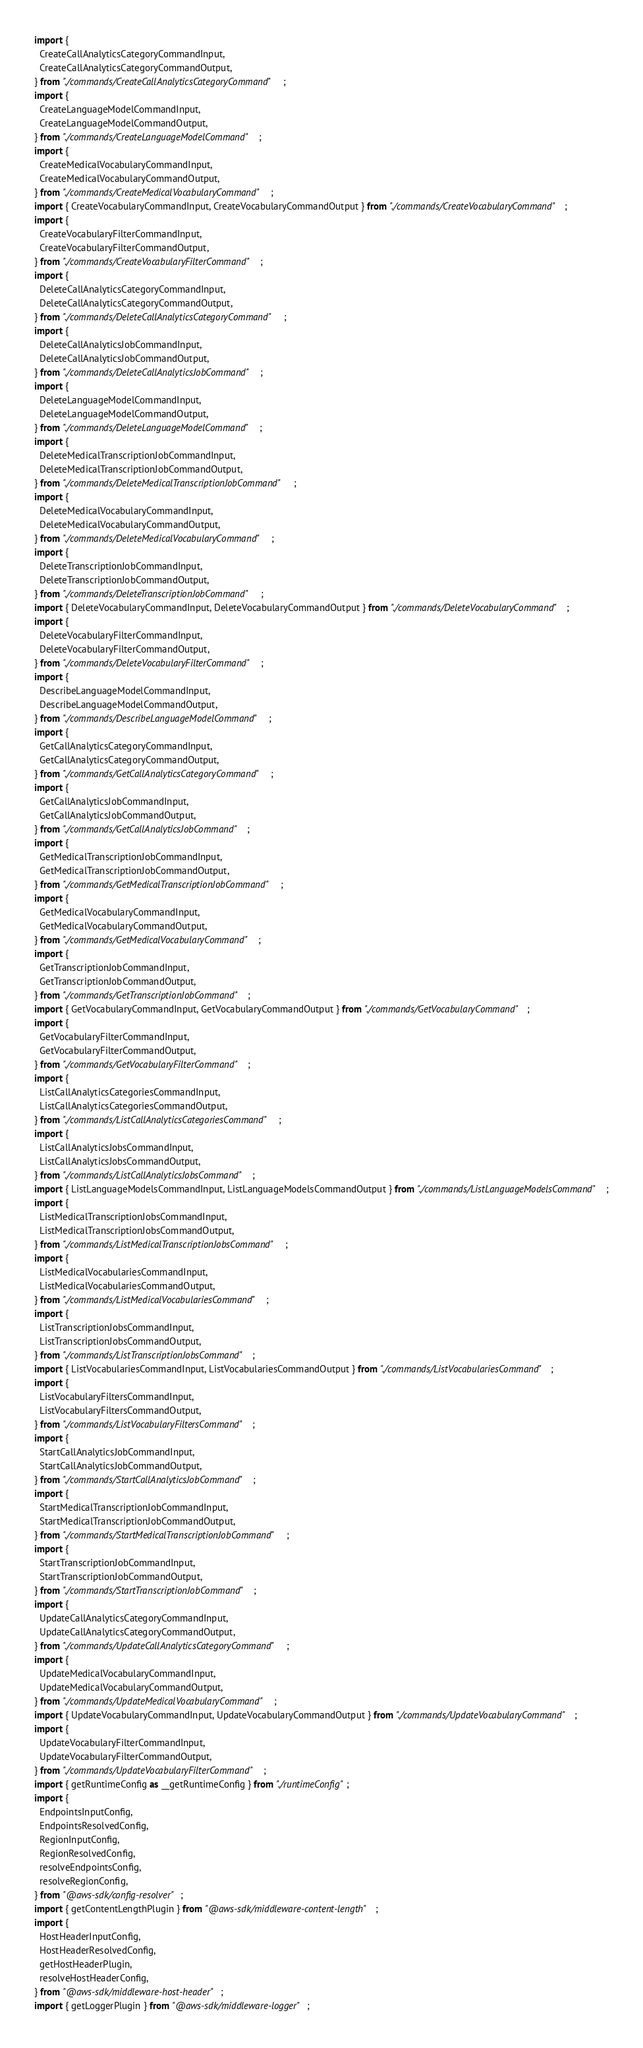Convert code to text. <code><loc_0><loc_0><loc_500><loc_500><_TypeScript_>import {
  CreateCallAnalyticsCategoryCommandInput,
  CreateCallAnalyticsCategoryCommandOutput,
} from "./commands/CreateCallAnalyticsCategoryCommand";
import {
  CreateLanguageModelCommandInput,
  CreateLanguageModelCommandOutput,
} from "./commands/CreateLanguageModelCommand";
import {
  CreateMedicalVocabularyCommandInput,
  CreateMedicalVocabularyCommandOutput,
} from "./commands/CreateMedicalVocabularyCommand";
import { CreateVocabularyCommandInput, CreateVocabularyCommandOutput } from "./commands/CreateVocabularyCommand";
import {
  CreateVocabularyFilterCommandInput,
  CreateVocabularyFilterCommandOutput,
} from "./commands/CreateVocabularyFilterCommand";
import {
  DeleteCallAnalyticsCategoryCommandInput,
  DeleteCallAnalyticsCategoryCommandOutput,
} from "./commands/DeleteCallAnalyticsCategoryCommand";
import {
  DeleteCallAnalyticsJobCommandInput,
  DeleteCallAnalyticsJobCommandOutput,
} from "./commands/DeleteCallAnalyticsJobCommand";
import {
  DeleteLanguageModelCommandInput,
  DeleteLanguageModelCommandOutput,
} from "./commands/DeleteLanguageModelCommand";
import {
  DeleteMedicalTranscriptionJobCommandInput,
  DeleteMedicalTranscriptionJobCommandOutput,
} from "./commands/DeleteMedicalTranscriptionJobCommand";
import {
  DeleteMedicalVocabularyCommandInput,
  DeleteMedicalVocabularyCommandOutput,
} from "./commands/DeleteMedicalVocabularyCommand";
import {
  DeleteTranscriptionJobCommandInput,
  DeleteTranscriptionJobCommandOutput,
} from "./commands/DeleteTranscriptionJobCommand";
import { DeleteVocabularyCommandInput, DeleteVocabularyCommandOutput } from "./commands/DeleteVocabularyCommand";
import {
  DeleteVocabularyFilterCommandInput,
  DeleteVocabularyFilterCommandOutput,
} from "./commands/DeleteVocabularyFilterCommand";
import {
  DescribeLanguageModelCommandInput,
  DescribeLanguageModelCommandOutput,
} from "./commands/DescribeLanguageModelCommand";
import {
  GetCallAnalyticsCategoryCommandInput,
  GetCallAnalyticsCategoryCommandOutput,
} from "./commands/GetCallAnalyticsCategoryCommand";
import {
  GetCallAnalyticsJobCommandInput,
  GetCallAnalyticsJobCommandOutput,
} from "./commands/GetCallAnalyticsJobCommand";
import {
  GetMedicalTranscriptionJobCommandInput,
  GetMedicalTranscriptionJobCommandOutput,
} from "./commands/GetMedicalTranscriptionJobCommand";
import {
  GetMedicalVocabularyCommandInput,
  GetMedicalVocabularyCommandOutput,
} from "./commands/GetMedicalVocabularyCommand";
import {
  GetTranscriptionJobCommandInput,
  GetTranscriptionJobCommandOutput,
} from "./commands/GetTranscriptionJobCommand";
import { GetVocabularyCommandInput, GetVocabularyCommandOutput } from "./commands/GetVocabularyCommand";
import {
  GetVocabularyFilterCommandInput,
  GetVocabularyFilterCommandOutput,
} from "./commands/GetVocabularyFilterCommand";
import {
  ListCallAnalyticsCategoriesCommandInput,
  ListCallAnalyticsCategoriesCommandOutput,
} from "./commands/ListCallAnalyticsCategoriesCommand";
import {
  ListCallAnalyticsJobsCommandInput,
  ListCallAnalyticsJobsCommandOutput,
} from "./commands/ListCallAnalyticsJobsCommand";
import { ListLanguageModelsCommandInput, ListLanguageModelsCommandOutput } from "./commands/ListLanguageModelsCommand";
import {
  ListMedicalTranscriptionJobsCommandInput,
  ListMedicalTranscriptionJobsCommandOutput,
} from "./commands/ListMedicalTranscriptionJobsCommand";
import {
  ListMedicalVocabulariesCommandInput,
  ListMedicalVocabulariesCommandOutput,
} from "./commands/ListMedicalVocabulariesCommand";
import {
  ListTranscriptionJobsCommandInput,
  ListTranscriptionJobsCommandOutput,
} from "./commands/ListTranscriptionJobsCommand";
import { ListVocabulariesCommandInput, ListVocabulariesCommandOutput } from "./commands/ListVocabulariesCommand";
import {
  ListVocabularyFiltersCommandInput,
  ListVocabularyFiltersCommandOutput,
} from "./commands/ListVocabularyFiltersCommand";
import {
  StartCallAnalyticsJobCommandInput,
  StartCallAnalyticsJobCommandOutput,
} from "./commands/StartCallAnalyticsJobCommand";
import {
  StartMedicalTranscriptionJobCommandInput,
  StartMedicalTranscriptionJobCommandOutput,
} from "./commands/StartMedicalTranscriptionJobCommand";
import {
  StartTranscriptionJobCommandInput,
  StartTranscriptionJobCommandOutput,
} from "./commands/StartTranscriptionJobCommand";
import {
  UpdateCallAnalyticsCategoryCommandInput,
  UpdateCallAnalyticsCategoryCommandOutput,
} from "./commands/UpdateCallAnalyticsCategoryCommand";
import {
  UpdateMedicalVocabularyCommandInput,
  UpdateMedicalVocabularyCommandOutput,
} from "./commands/UpdateMedicalVocabularyCommand";
import { UpdateVocabularyCommandInput, UpdateVocabularyCommandOutput } from "./commands/UpdateVocabularyCommand";
import {
  UpdateVocabularyFilterCommandInput,
  UpdateVocabularyFilterCommandOutput,
} from "./commands/UpdateVocabularyFilterCommand";
import { getRuntimeConfig as __getRuntimeConfig } from "./runtimeConfig";
import {
  EndpointsInputConfig,
  EndpointsResolvedConfig,
  RegionInputConfig,
  RegionResolvedConfig,
  resolveEndpointsConfig,
  resolveRegionConfig,
} from "@aws-sdk/config-resolver";
import { getContentLengthPlugin } from "@aws-sdk/middleware-content-length";
import {
  HostHeaderInputConfig,
  HostHeaderResolvedConfig,
  getHostHeaderPlugin,
  resolveHostHeaderConfig,
} from "@aws-sdk/middleware-host-header";
import { getLoggerPlugin } from "@aws-sdk/middleware-logger";</code> 